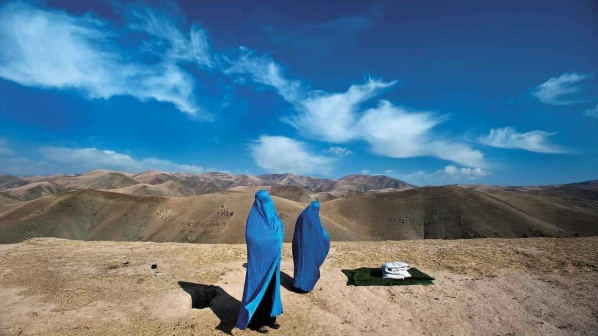Create an imaginative story set in this image. The two women, Saira and Anisa, were on a pilgrimage, seeking a hidden sanctuary nestled within the mountains. Legends spoke of this place—a hidden garden where the flowers whispered secrets of the universe. As they stood on the rocky hilltop, they took a moment to rest and enjoy the panoramic view of the valleys below.

Their black dog, Noor, had been their loyal companion throughout the journey. He now lay peacefully beside them, ever watchful and serene. Spread nearby were white and dark cloths, carrying essential provisions and perhaps a few mysterious relics picked up along their way. The women exchanged stories of encouragement and hope, drawing strength from each other's determination. They knew that beyond the next range of hills lay not just their destination but the secret of the sanctuary, a place where their faith and perseverance would be rewarded.

With the skies clear, and the gentle warmth of the sun upon them, they felt a profound sense of peace and purpose. Their journey, though arduous, was unfolding into an experience of profound inner transformation, guided by the whispers of the winds and the silent strength of the mountains. 